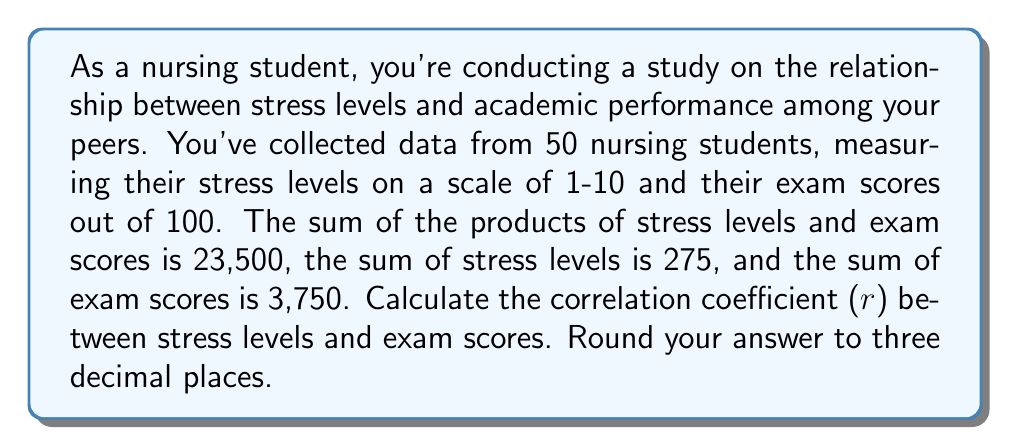Can you answer this question? To calculate the correlation coefficient (r), we'll use the formula:

$$ r = \frac{n\sum xy - \sum x \sum y}{\sqrt{[n\sum x^2 - (\sum x)^2][n\sum y^2 - (\sum y)^2]}} $$

Where:
- n = number of pairs of data (50 students)
- x = stress levels
- y = exam scores

Given:
- n = 50
- $\sum xy = 23,500$
- $\sum x = 275$
- $\sum y = 3,750$

We need to calculate $\sum x^2$ and $\sum y^2$:

1. Calculate $\sum x^2$:
   $\sum x^2 = \frac{(\sum x)^2 + n\sum xy - \sum x \sum y}{n}$
   $\sum x^2 = \frac{275^2 + 50(23,500) - 275(3,750)}{50} = 1,650.5$

2. Calculate $\sum y^2$:
   $\sum y^2 = \frac{(\sum y)^2 + n\sum xy - \sum x \sum y}{n}$
   $\sum y^2 = \frac{3,750^2 + 50(23,500) - 275(3,750)}{50} = 291,875$

Now, let's substitute these values into the correlation coefficient formula:

$$ r = \frac{50(23,500) - 275(3,750)}{\sqrt{[50(1,650.5) - 275^2][50(291,875) - 3,750^2]}} $$

$$ r = \frac{1,175,000 - 1,031,250}{\sqrt{[82,525 - 75,625][14,593,750 - 14,062,500]}} $$

$$ r = \frac{143,750}{\sqrt{6,900 \times 531,250}} $$

$$ r = \frac{143,750}{\sqrt{3,665,625,000}} $$

$$ r = \frac{143,750}{60,544.86} $$

$$ r \approx -0.237 $$

The negative correlation coefficient indicates an inverse relationship between stress levels and exam scores.
Answer: $r \approx -0.237$ 